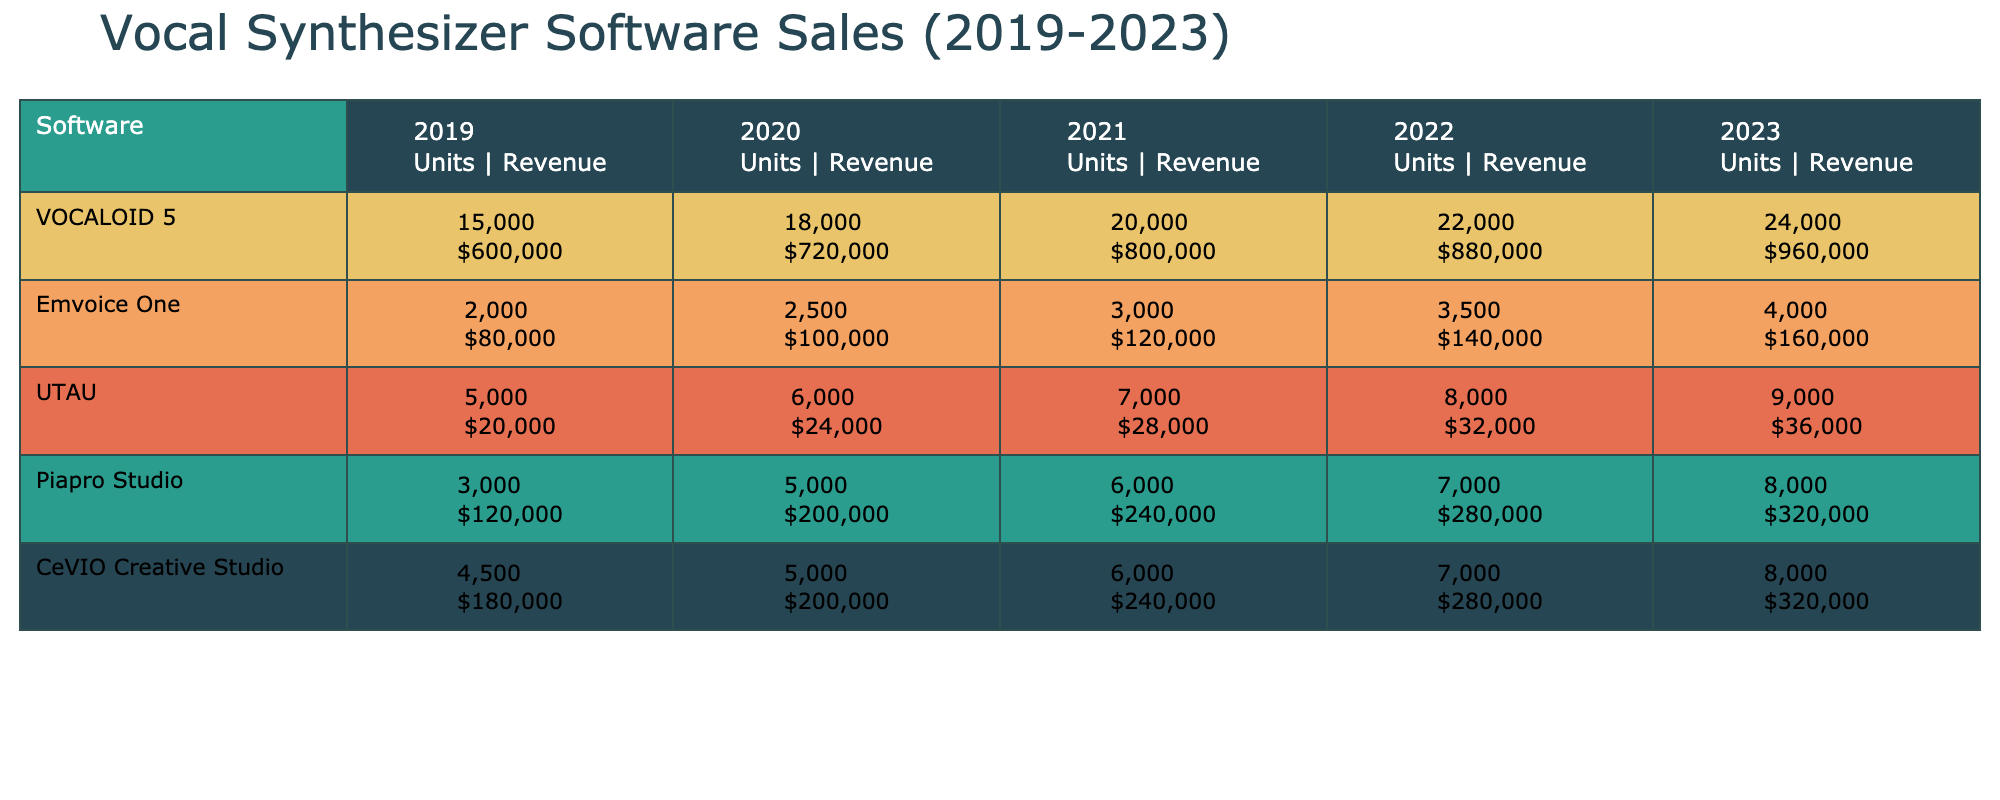What was the total sales units for VOCALOID 5 in 2021? From the table, VOCALOID 5 had sales units of 20,000 in 2021.
Answer: 20,000 Which software had the highest revenue in 2022? By checking the revenue columns for 2022, VOCALOID 5 had the highest revenue of $880,000.
Answer: VOCALOID 5 What is the percentage increase in sales units for Emvoice One from 2020 to 2023? Emvoice One sold 2,500 units in 2020 and 4,000 units in 2023. The increase is 4,000 - 2,500 = 1,500 units. The percentage increase is (1,500 / 2,500) * 100 = 60%.
Answer: 60% Did UTAU show an increase in sales revenue every year from 2019 to 2023? UTAU's revenue in 2019 was $20,000, in 2020 it was $24,000 (increase), in 2021 it was $28,000 (increase), in 2022 it was $32,000 (increase), but in 2023 it was $36,000 (increase). Therefore, UTAU did show an increase every year.
Answer: Yes What software had the greatest overall sales units from 2019 to 2023? Summing the sales units from the table for each software: VOCALOID 5 (96,000), Emvoice One (15,000), UTAU (42,000), Piapro Studio (37,000), CeVIO Creative Studio (38,000). The greatest overall sales units belong to VOCALOID 5 with 96,000 sales.
Answer: VOCALOID 5 How much more revenue did Piapro Studio generate in 2023 compared to 2019? Piapro Studio had revenues of $120,000 in 2019 and $320,000 in 2023. The difference is $320,000 - $120,000 = $200,000.
Answer: $200,000 What was the average revenue across all software in 2020? The total revenue for all software in 2020 is $720,000 + $100,000 + $24,000 + $200,000 + $200,000 = $1,244,000. There are 5 software, so the average is $1,244,000 / 5 = $248,800.
Answer: $248,800 Was there a decline in sales units for any software from 2019 to 2023? By checking the sales units for each software over the years, there was no decline in sales units for any software from 2019 to 2023; all showed increases.
Answer: No What was the total sales revenue for CeVIO Creative Studio from 2019 to 2023? Adding revenue for CeVIO: $180,000 + $200,000 + $240,000 + $280,000 + $320,000 = $1,220,000.
Answer: $1,220,000 Which years did Emvoice One record an increase in sales revenue? Emvoice One's revenue was $80,000 in 2019, $100,000 in 2020 (increase), $120,000 in 2021 (increase), $140,000 in 2022 (increase), and $160,000 in 2023 (increase). Emvoice One recorded an increase every year.
Answer: Yes 